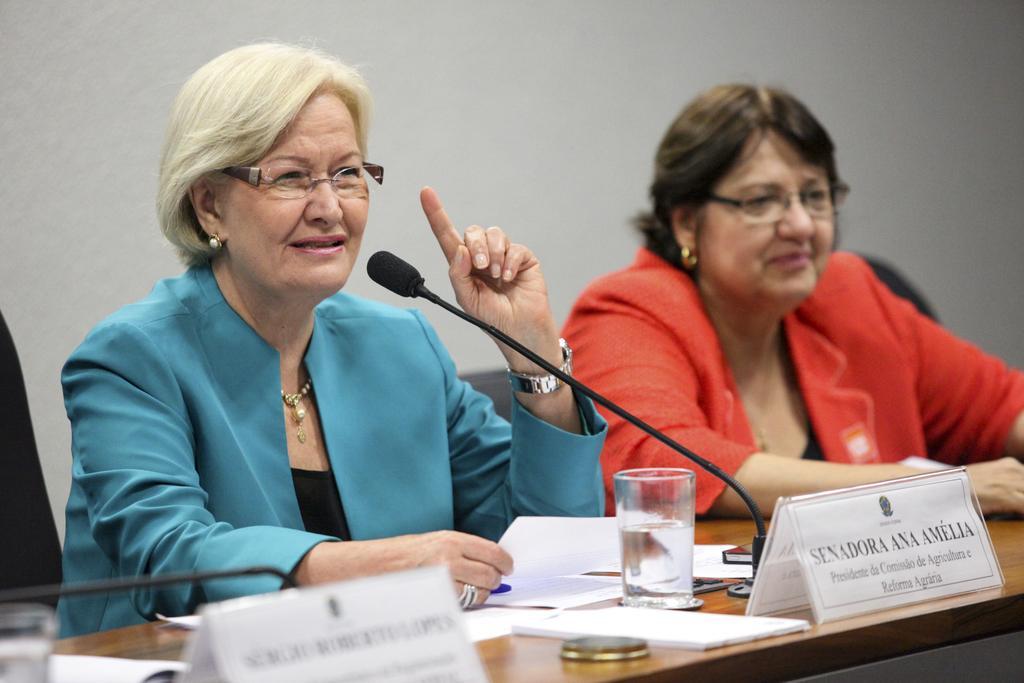Can you describe this image briefly? In this picture I can see two people sitting on the chairs. I can see the microphones. I can see name plates. I can see the glass and papers on the table. 